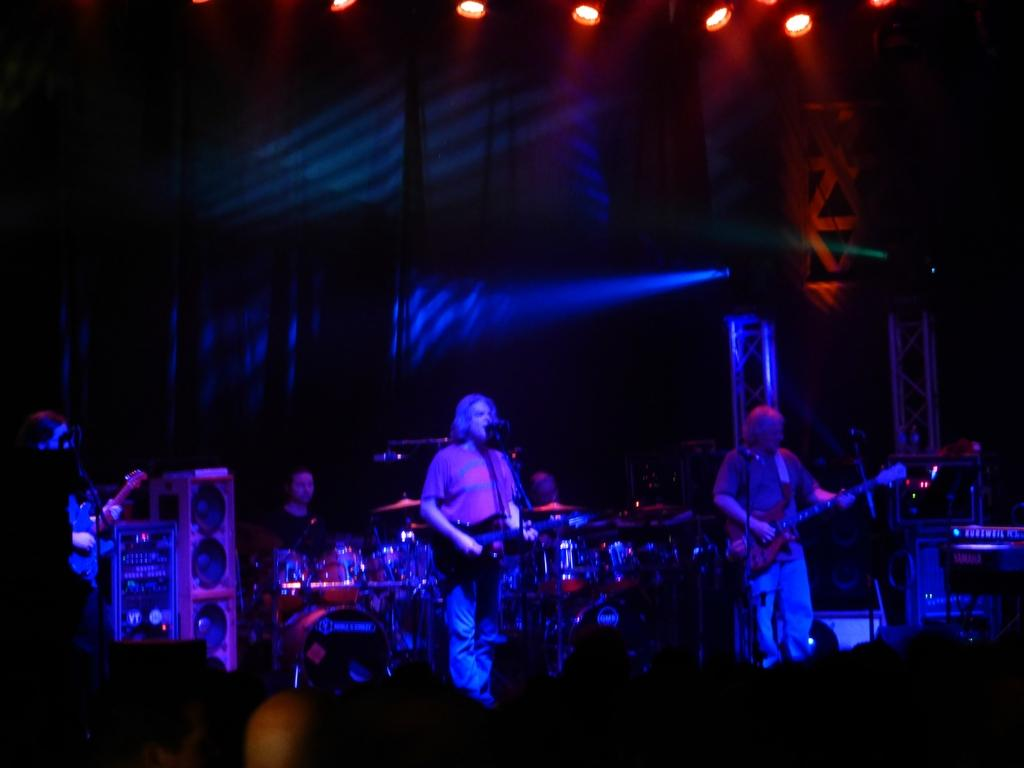How many people are in the image? There are three persons in the image. What are the three persons doing? Each of the three persons is holding a guitar and playing it. Is there anyone else in the image besides the three guitar players? Yes, there is a person playing electronic drums in the image. What can be seen in the image that might be used for amplifying sound? There are speakers visible in the image. What can be seen in the image that might provide illumination? There are lights visible in the image. Can you see a tiger playing the drums in the image? No, there is no tiger present in the image. What type of flame can be seen coming from the guitar in the image? There is no flame visible in the image; it is a group of people playing musical instruments. 